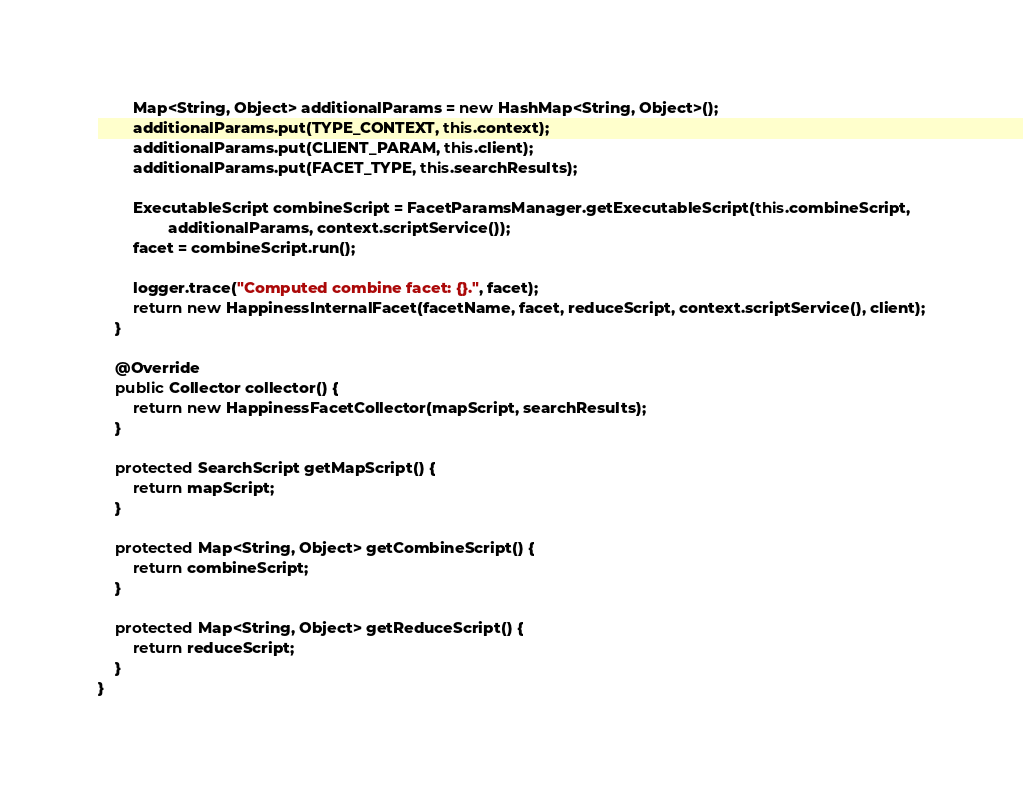<code> <loc_0><loc_0><loc_500><loc_500><_Java_>
		Map<String, Object> additionalParams = new HashMap<String, Object>();
		additionalParams.put(TYPE_CONTEXT, this.context);
		additionalParams.put(CLIENT_PARAM, this.client);
		additionalParams.put(FACET_TYPE, this.searchResults);

		ExecutableScript combineScript = FacetParamsManager.getExecutableScript(this.combineScript,
				additionalParams, context.scriptService());
		facet = combineScript.run();

		logger.trace("Computed combine facet: {}.", facet);
		return new HappinessInternalFacet(facetName, facet, reduceScript, context.scriptService(), client);
	}

	@Override
	public Collector collector() {
		return new HappinessFacetCollector(mapScript, searchResults);
	}

	protected SearchScript getMapScript() {
		return mapScript;
	}

	protected Map<String, Object> getCombineScript() {
		return combineScript;
	}

	protected Map<String, Object> getReduceScript() {
		return reduceScript;
	}
}</code> 